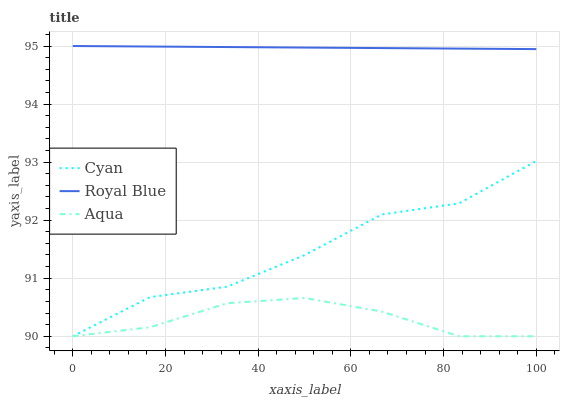Does Royal Blue have the minimum area under the curve?
Answer yes or no. No. Does Aqua have the maximum area under the curve?
Answer yes or no. No. Is Aqua the smoothest?
Answer yes or no. No. Is Aqua the roughest?
Answer yes or no. No. Does Royal Blue have the lowest value?
Answer yes or no. No. Does Aqua have the highest value?
Answer yes or no. No. Is Aqua less than Royal Blue?
Answer yes or no. Yes. Is Royal Blue greater than Cyan?
Answer yes or no. Yes. Does Aqua intersect Royal Blue?
Answer yes or no. No. 